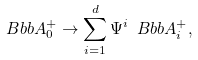<formula> <loc_0><loc_0><loc_500><loc_500>\ B b b { A } _ { 0 } ^ { + } \rightarrow \sum _ { i = 1 } ^ { d } \Psi ^ { i } \ B b b { A } _ { i } ^ { + } ,</formula> 